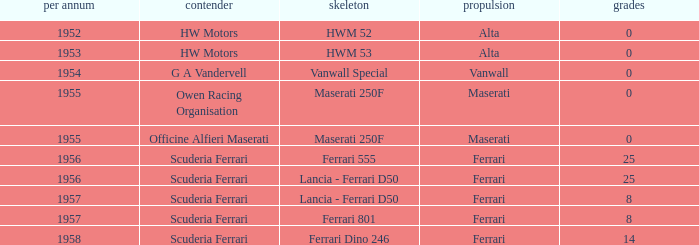What is the entrant earlier than 1956 with a Vanwall Special chassis? G A Vandervell. 